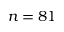Convert formula to latex. <formula><loc_0><loc_0><loc_500><loc_500>n = 8 1</formula> 